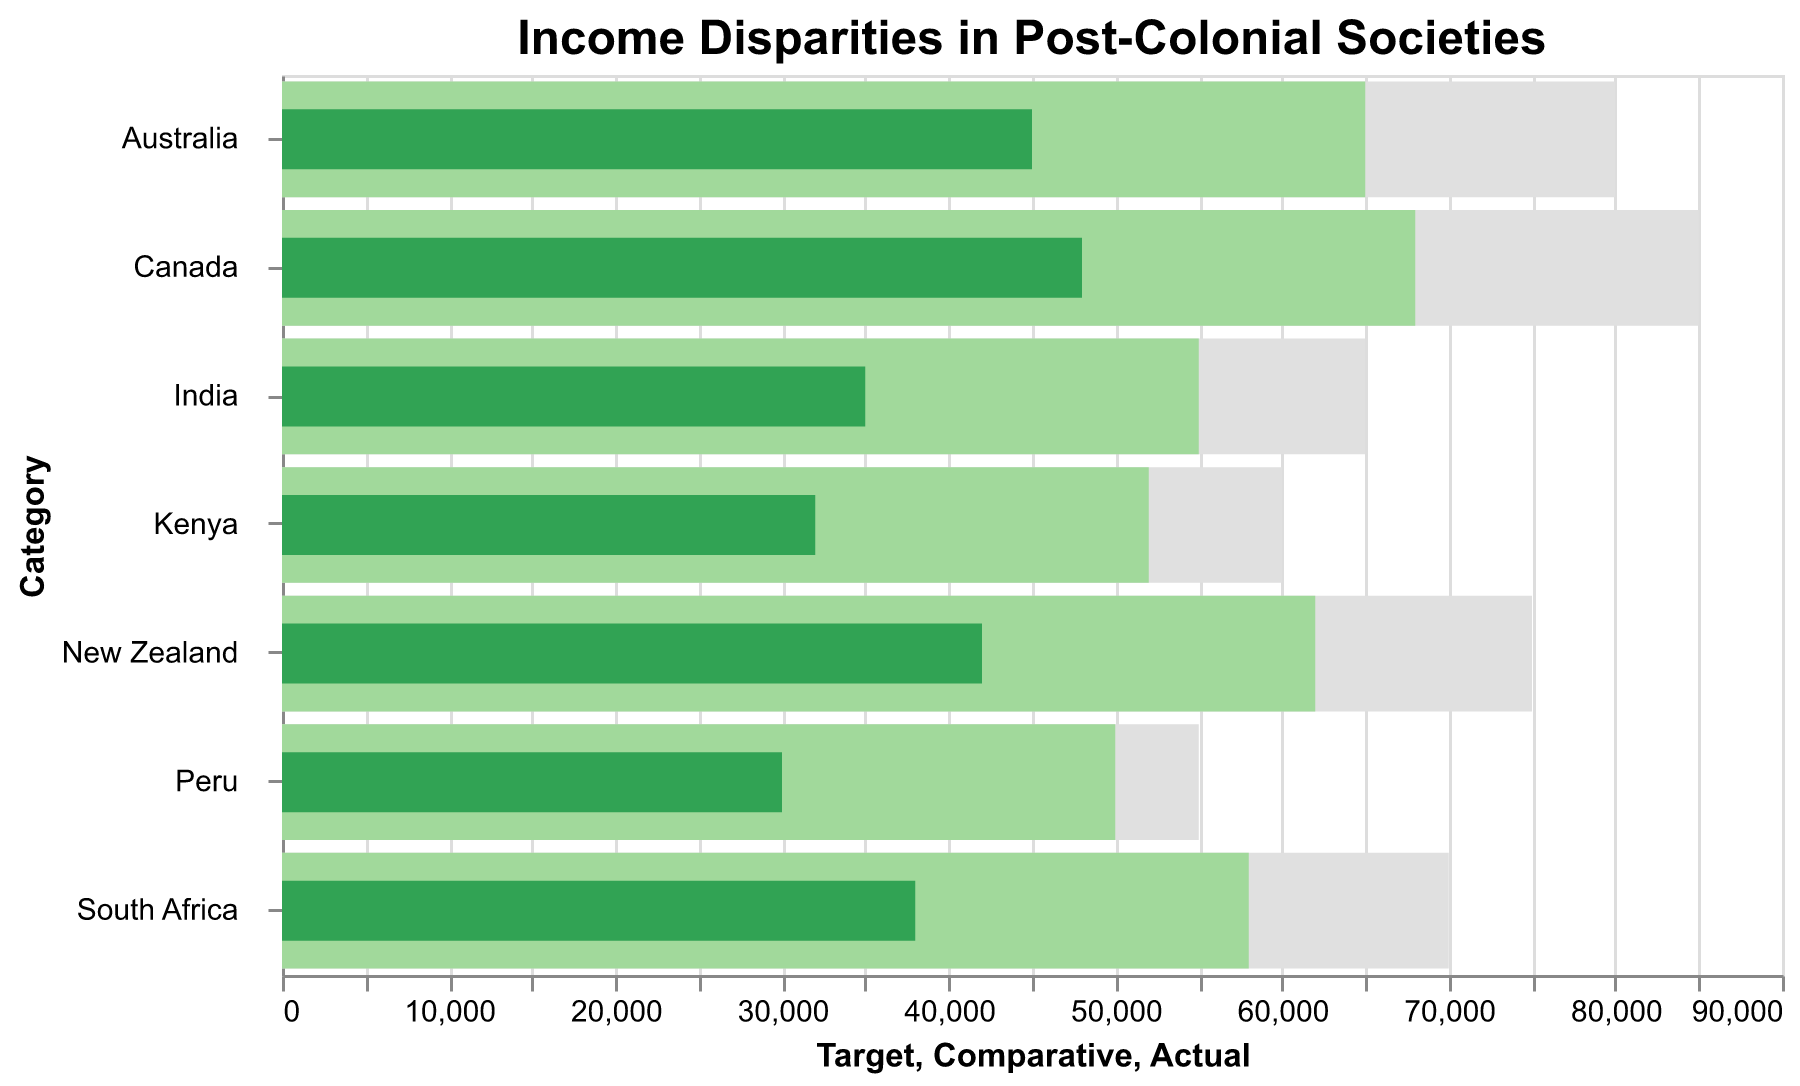what is the title of the figure? The title of the figure is usually displayed prominently at the top. According to the details provided, we know that the title of the figure is "Income Disparities in Post-Colonial Societies."
Answer: Income Disparities in Post-Colonial Societies What is the actual income for Canada? The actual income for each country is represented by a green bar (color #31a354) in the bullet chart. For Canada, the actual income is shown as 48000.
Answer: 48000 What country has the lowest target income and what is its value? The target income is represented by the longest grey bar in the chart for each country. Peru has the shortest grey bar indicating a target income of 55000.
Answer: Peru, 55000 How does the actual income of South Africa compare to its target income? To compare the actual income with the target income, look at the green bar and the longest grey bar for South Africa. The actual income (38000) is less than the target income (70000).
Answer: Less than the target income What is the difference between the comparative income and the actual income in New Zealand? The comparative income for New Zealand is 62000, and the actual income is 42000. The difference is calculated as 62000 - 42000.
Answer: 20000 Which country has the highest comparative income and what is its value? The tallest green-shaded bar represents the comparative income for each country. Canada has the tallest green bar with a value of 68000.
Answer: Canada, 68000 How does the actual income in Australia compare to the actual income in Kenya? The actual income in Australia is 45000, while in Kenya, it is 32000. Australia has a higher actual income than Kenya.
Answer: Australia is higher What is the average target income across all countries? Sum the target incomes (80000 + 75000 + 85000 + 70000 + 65000 + 60000 + 55000 = 490000) and divide by the number of data points (7). The average target income is 490000 / 7.
Answer: 70000 What percentage of the target income does Australia's actual income represent? Australia's actual income is 45000 and its target income is 80000. The percentage is calculated as (45000 / 80000) * 100.
Answer: 56.25% How much higher is the comparative income for Canada compared to India? The comparative income for Canada is 68000, while for India, it is 55000. The difference is calculated as 68000 - 55000.
Answer: 13000 